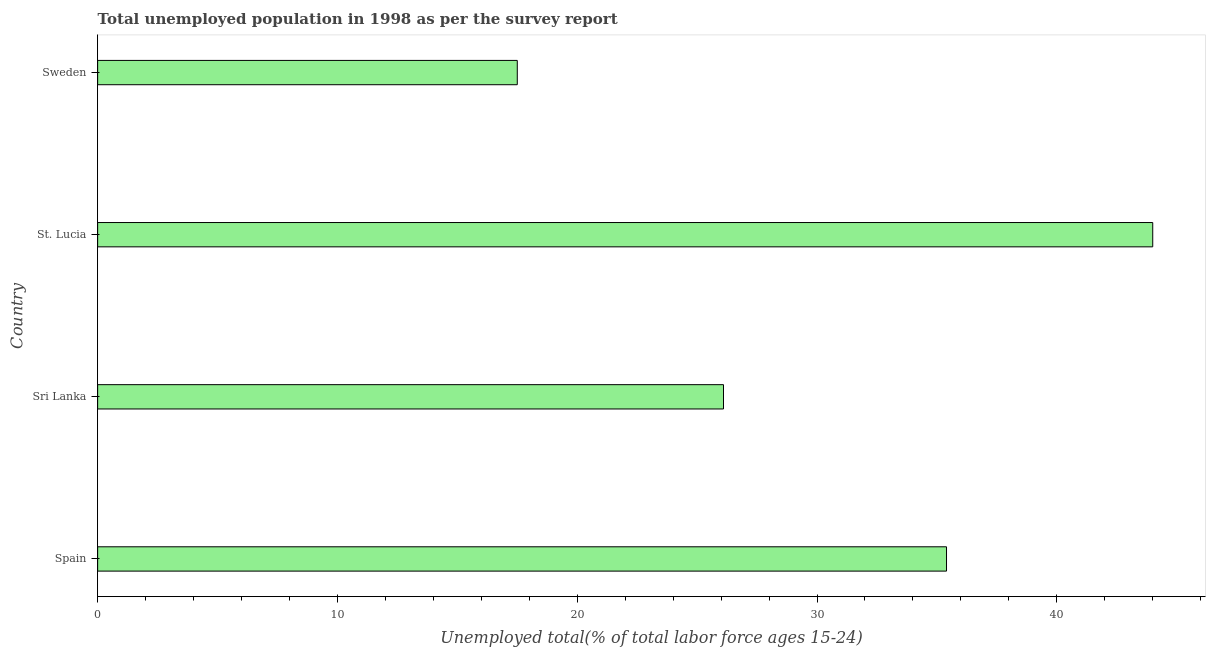Does the graph contain any zero values?
Offer a very short reply. No. What is the title of the graph?
Offer a terse response. Total unemployed population in 1998 as per the survey report. What is the label or title of the X-axis?
Your answer should be very brief. Unemployed total(% of total labor force ages 15-24). What is the unemployed youth in Spain?
Your answer should be compact. 35.4. Across all countries, what is the minimum unemployed youth?
Make the answer very short. 17.5. In which country was the unemployed youth maximum?
Your answer should be very brief. St. Lucia. What is the sum of the unemployed youth?
Make the answer very short. 123. What is the average unemployed youth per country?
Ensure brevity in your answer.  30.75. What is the median unemployed youth?
Your response must be concise. 30.75. In how many countries, is the unemployed youth greater than 32 %?
Provide a succinct answer. 2. What is the ratio of the unemployed youth in Spain to that in Sri Lanka?
Your answer should be compact. 1.36. Is the difference between the unemployed youth in Spain and Sweden greater than the difference between any two countries?
Offer a terse response. No. What is the difference between the highest and the second highest unemployed youth?
Make the answer very short. 8.6. Is the sum of the unemployed youth in Spain and Sweden greater than the maximum unemployed youth across all countries?
Your answer should be very brief. Yes. What is the difference between the highest and the lowest unemployed youth?
Give a very brief answer. 26.5. How many bars are there?
Provide a short and direct response. 4. What is the Unemployed total(% of total labor force ages 15-24) of Spain?
Give a very brief answer. 35.4. What is the Unemployed total(% of total labor force ages 15-24) in Sri Lanka?
Offer a very short reply. 26.1. What is the Unemployed total(% of total labor force ages 15-24) of Sweden?
Make the answer very short. 17.5. What is the difference between the Unemployed total(% of total labor force ages 15-24) in Sri Lanka and St. Lucia?
Keep it short and to the point. -17.9. What is the difference between the Unemployed total(% of total labor force ages 15-24) in Sri Lanka and Sweden?
Provide a short and direct response. 8.6. What is the difference between the Unemployed total(% of total labor force ages 15-24) in St. Lucia and Sweden?
Keep it short and to the point. 26.5. What is the ratio of the Unemployed total(% of total labor force ages 15-24) in Spain to that in Sri Lanka?
Your answer should be very brief. 1.36. What is the ratio of the Unemployed total(% of total labor force ages 15-24) in Spain to that in St. Lucia?
Your answer should be compact. 0.81. What is the ratio of the Unemployed total(% of total labor force ages 15-24) in Spain to that in Sweden?
Offer a terse response. 2.02. What is the ratio of the Unemployed total(% of total labor force ages 15-24) in Sri Lanka to that in St. Lucia?
Provide a succinct answer. 0.59. What is the ratio of the Unemployed total(% of total labor force ages 15-24) in Sri Lanka to that in Sweden?
Your response must be concise. 1.49. What is the ratio of the Unemployed total(% of total labor force ages 15-24) in St. Lucia to that in Sweden?
Make the answer very short. 2.51. 